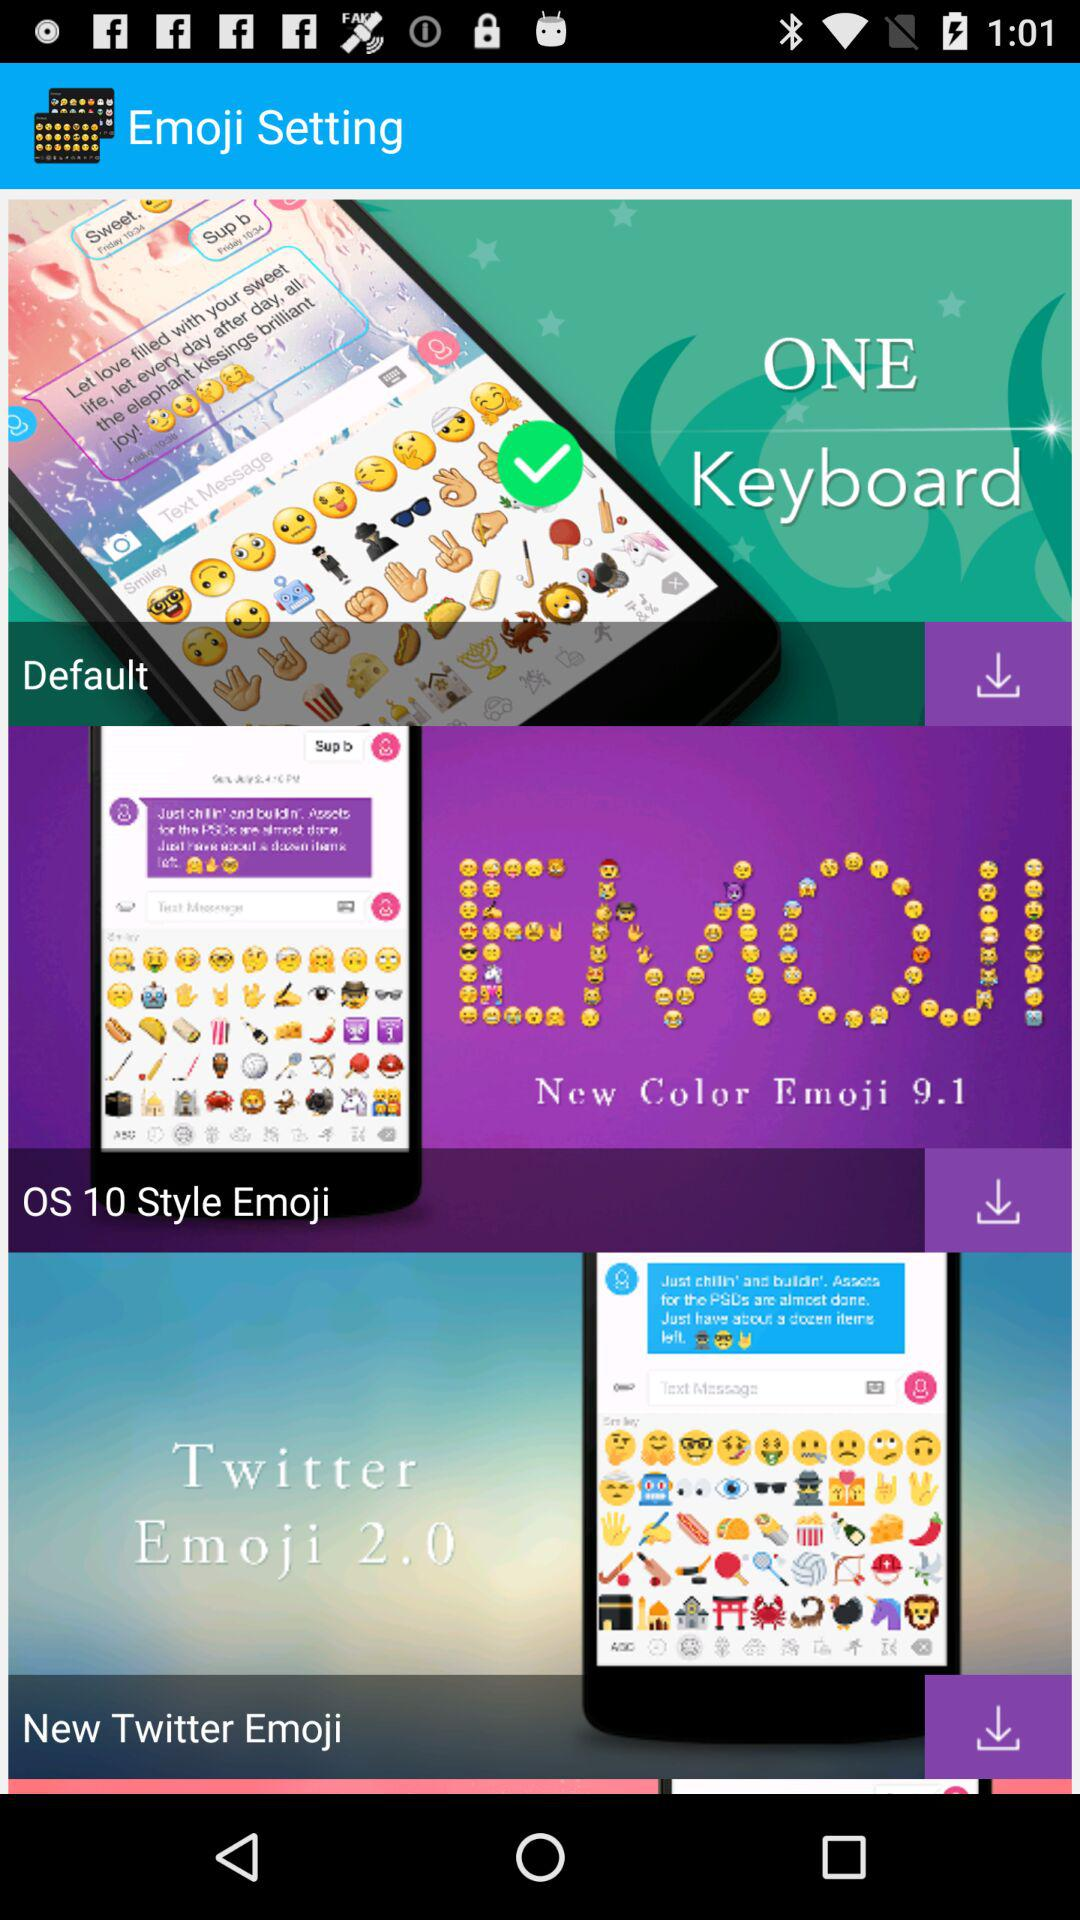Which emoji theme is selected? The selected emoji theme is "Default". 